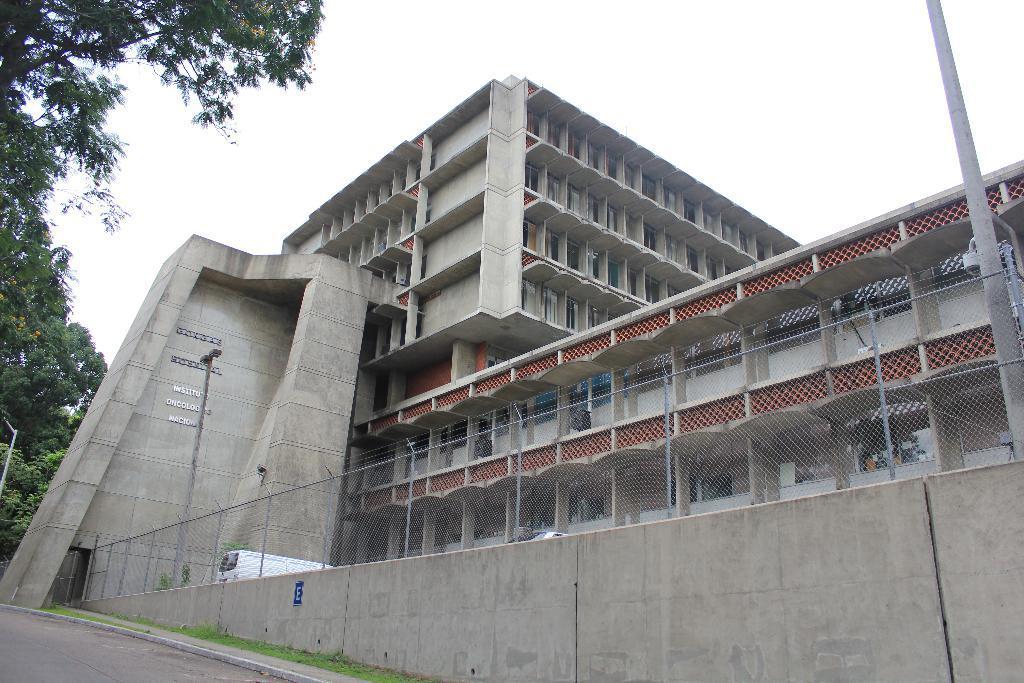Could you give a brief overview of what you see in this image? In this image there are buildings, poles, railing, wall and there is a train. At the bottom there is grass and road, and on the left side of the image there are trees. At the top there is sky. 